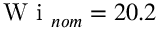<formula> <loc_0><loc_0><loc_500><loc_500>W i _ { n o m } = 2 0 . 2</formula> 